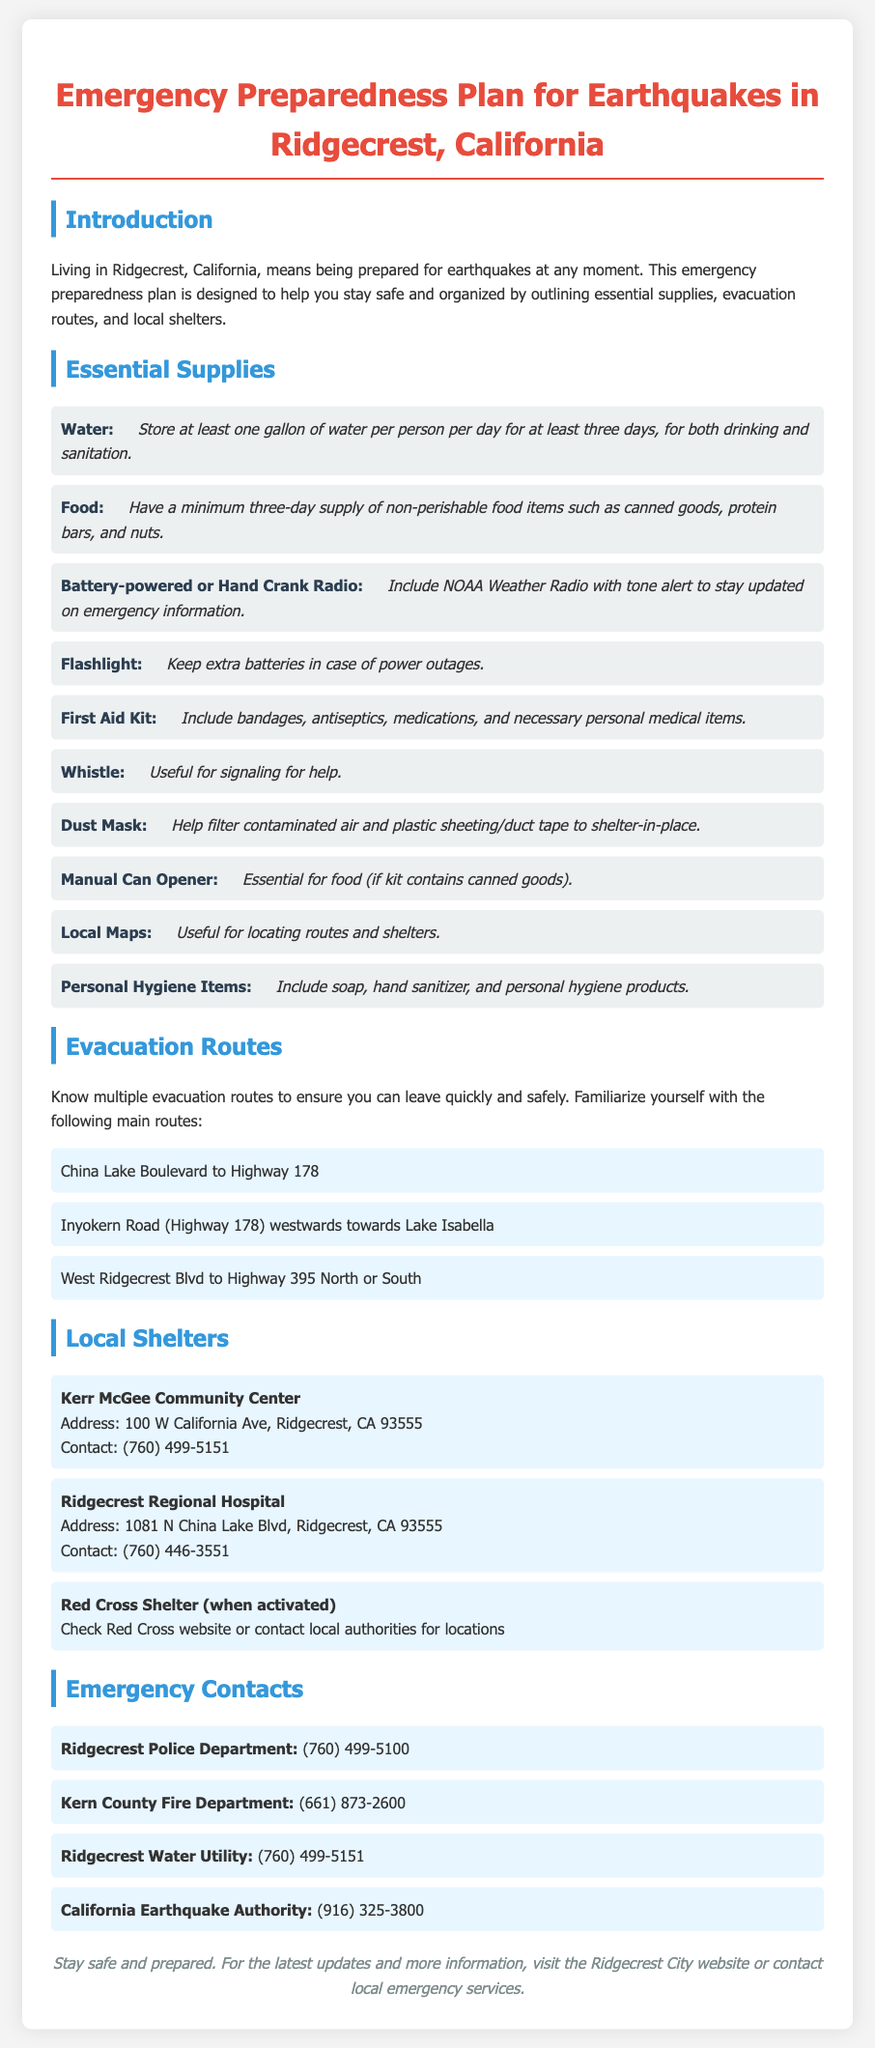What is the minimum water supply recommended per person? The document states to store at least one gallon of water per person per day for at least three days.
Answer: one gallon What should you keep for updates on emergency information? The document specifies including a battery-powered or hand crank radio with NOAA Weather Radio with tone alert.
Answer: battery-powered or hand crank radio What is one evacuation route mentioned in the document? The document lists several routes, one of which is China Lake Boulevard to Highway 178.
Answer: China Lake Boulevard to Highway 178 What is the address of the Kerr McGee Community Center? The document provides the specific address for the community center which is listed.
Answer: 100 W California Ave, Ridgecrest, CA 93555 What type of items should you include for personal hygiene? The document mentions including soap, hand sanitizer, and personal hygiene products under essential supplies.
Answer: soap, hand sanitizer, and personal hygiene products What contact number is provided for the Ridgecrest Police Department? The document specifies the contact number for the police department.
Answer: (760) 499-5100 What is necessary besides food and water in the essential supplies? The document describes several necessary items, among which is a first aid kit that must be included.
Answer: first aid kit Why is it important to have local maps in your supplies? The document notes that local maps are useful for locating routes and shelters during an emergency.
Answer: locating routes and shelters 